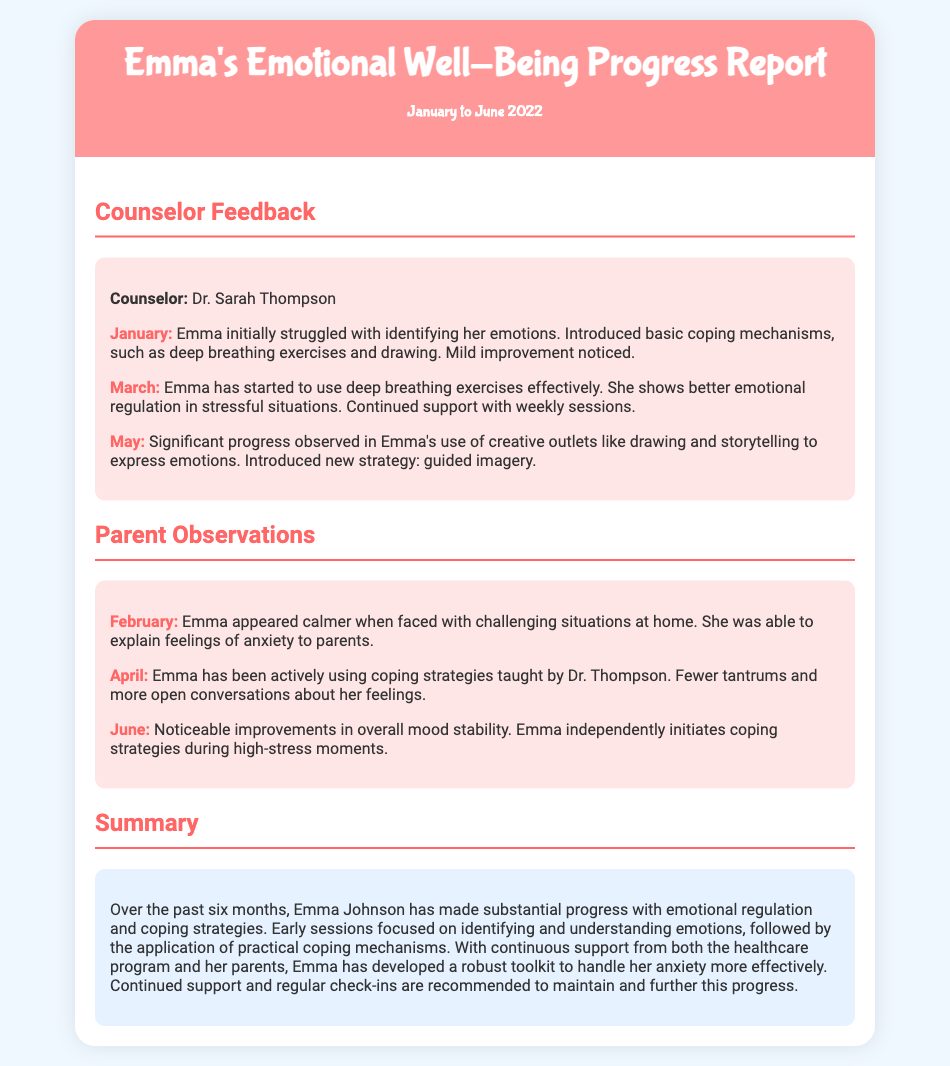What is the name of the counselor? The counselor's name is stated at the beginning of the feedback section, which identifies Dr. Sarah Thompson.
Answer: Dr. Sarah Thompson In which month did Emma show better emotional regulation? The month when Emma showed better emotional regulation is mentioned in the feedback from March, where it states she has started to use deep breathing exercises effectively.
Answer: March What creative outlets did Emma use to express her emotions? The document notes that Emma used drawing and storytelling as creative outlets for expressing her emotions in May.
Answer: Drawing and storytelling How many parent observations are recorded in the document? The document includes a total of three parent observations, one for each of the months mentioned: February, April, and June.
Answer: Three What coping strategy was introduced in May? The introduction of a new coping strategy is noted in the feedback for May, specifically guided imagery.
Answer: Guided imagery What overall progress has Emma made regarding her emotional regulation? The summary at the end of the document highlights that Emma has made substantial progress in emotional regulation and coping strategies over six months.
Answer: Substantial progress How did Emma's behavior change by June according to parent observations? The June observation mentions noticeable improvements in Emma's overall mood stability and her independent use of coping strategies during high-stress moments.
Answer: Noticeable improvements What specific issue did Emma initially struggle with? The document states that in January, Emma initially struggled with identifying her emotions, as noted in the feedback section.
Answer: Identifying her emotions 